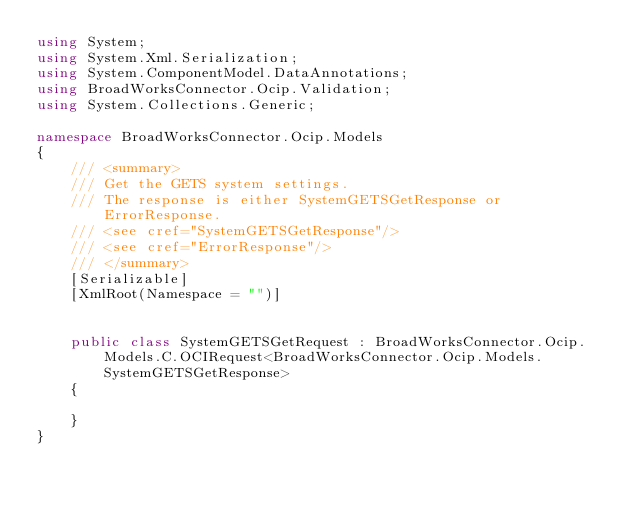Convert code to text. <code><loc_0><loc_0><loc_500><loc_500><_C#_>using System;
using System.Xml.Serialization;
using System.ComponentModel.DataAnnotations;
using BroadWorksConnector.Ocip.Validation;
using System.Collections.Generic;

namespace BroadWorksConnector.Ocip.Models
{
    /// <summary>
    /// Get the GETS system settings.
    /// The response is either SystemGETSGetResponse or ErrorResponse.
    /// <see cref="SystemGETSGetResponse"/>
    /// <see cref="ErrorResponse"/>
    /// </summary>
    [Serializable]
    [XmlRoot(Namespace = "")]


    public class SystemGETSGetRequest : BroadWorksConnector.Ocip.Models.C.OCIRequest<BroadWorksConnector.Ocip.Models.SystemGETSGetResponse>
    {

    }
}
</code> 